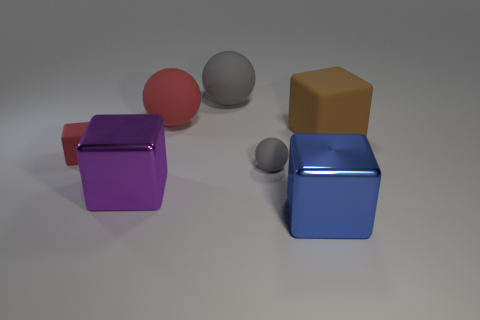There is a big cube that is to the left of the big blue thing; what material is it?
Give a very brief answer. Metal. There is a cube that is behind the small object that is behind the gray matte sphere that is in front of the small cube; what is its color?
Your answer should be compact. Brown. There is a matte block that is the same size as the purple metal object; what color is it?
Provide a succinct answer. Brown. What number of shiny objects are either blocks or large blocks?
Offer a terse response. 2. What is the color of the tiny cube that is the same material as the big gray thing?
Your answer should be very brief. Red. What material is the red thing in front of the object on the right side of the blue metal object made of?
Provide a succinct answer. Rubber. How many things are either big things behind the blue shiny thing or cubes that are behind the tiny red object?
Provide a short and direct response. 4. There is a metallic cube behind the shiny thing right of the red matte object that is to the right of the big purple metallic thing; how big is it?
Your answer should be very brief. Large. Are there the same number of big blue shiny cubes behind the small matte sphere and gray objects?
Give a very brief answer. No. Is there anything else that is the same shape as the big brown object?
Ensure brevity in your answer.  Yes. 